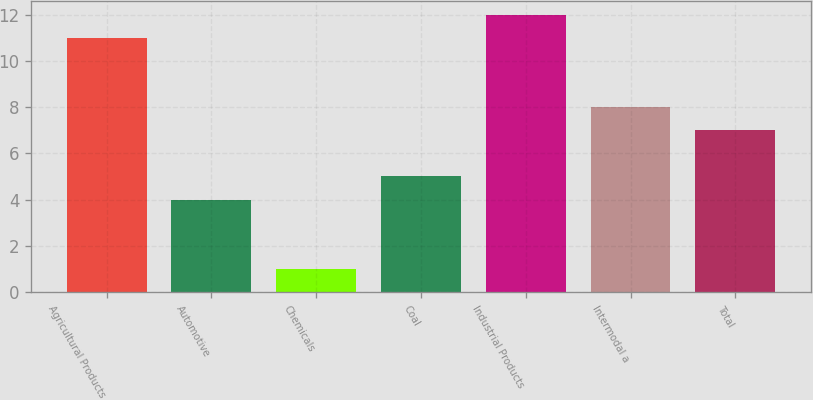Convert chart to OTSL. <chart><loc_0><loc_0><loc_500><loc_500><bar_chart><fcel>Agricultural Products<fcel>Automotive<fcel>Chemicals<fcel>Coal<fcel>Industrial Products<fcel>Intermodal a<fcel>Total<nl><fcel>11<fcel>4<fcel>1<fcel>5<fcel>12<fcel>8<fcel>7<nl></chart> 